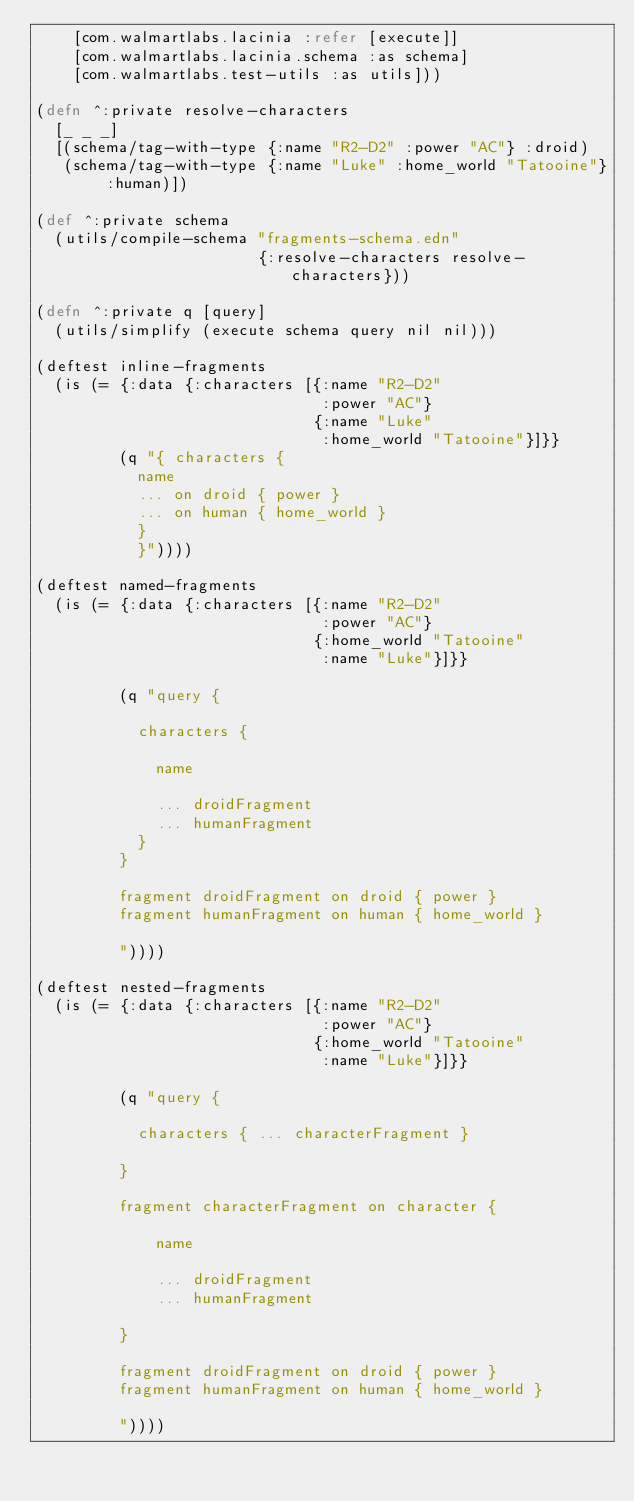<code> <loc_0><loc_0><loc_500><loc_500><_Clojure_>    [com.walmartlabs.lacinia :refer [execute]]
    [com.walmartlabs.lacinia.schema :as schema]
    [com.walmartlabs.test-utils :as utils]))

(defn ^:private resolve-characters
  [_ _ _]
  [(schema/tag-with-type {:name "R2-D2" :power "AC"} :droid)
   (schema/tag-with-type {:name "Luke" :home_world "Tatooine"} :human)])

(def ^:private schema
  (utils/compile-schema "fragments-schema.edn"
                        {:resolve-characters resolve-characters}))

(defn ^:private q [query]
  (utils/simplify (execute schema query nil nil)))

(deftest inline-fragments
  (is (= {:data {:characters [{:name "R2-D2"
                               :power "AC"}
                              {:name "Luke"
                               :home_world "Tatooine"}]}}
         (q "{ characters {
           name
           ... on droid { power }
           ... on human { home_world }
           }
           }"))))

(deftest named-fragments
  (is (= {:data {:characters [{:name "R2-D2"
                               :power "AC"}
                              {:home_world "Tatooine"
                               :name "Luke"}]}}

         (q "query {

           characters {

             name

             ... droidFragment
             ... humanFragment
           }
         }

         fragment droidFragment on droid { power }
         fragment humanFragment on human { home_world }

         "))))

(deftest nested-fragments
  (is (= {:data {:characters [{:name "R2-D2"
                               :power "AC"}
                              {:home_world "Tatooine"
                               :name "Luke"}]}}

         (q "query {

           characters { ... characterFragment }

         }

         fragment characterFragment on character {

             name

             ... droidFragment
             ... humanFragment

         }

         fragment droidFragment on droid { power }
         fragment humanFragment on human { home_world }

         "))))
</code> 